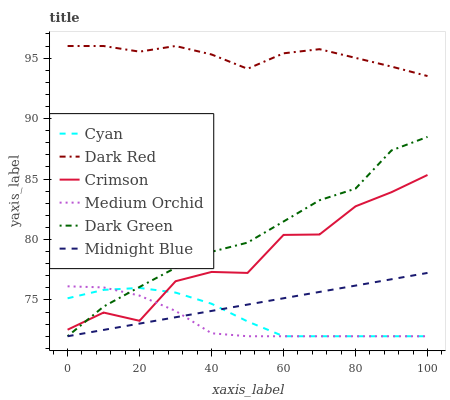Does Medium Orchid have the minimum area under the curve?
Answer yes or no. Yes. Does Dark Red have the maximum area under the curve?
Answer yes or no. Yes. Does Dark Red have the minimum area under the curve?
Answer yes or no. No. Does Medium Orchid have the maximum area under the curve?
Answer yes or no. No. Is Midnight Blue the smoothest?
Answer yes or no. Yes. Is Crimson the roughest?
Answer yes or no. Yes. Is Dark Red the smoothest?
Answer yes or no. No. Is Dark Red the roughest?
Answer yes or no. No. Does Midnight Blue have the lowest value?
Answer yes or no. Yes. Does Dark Red have the lowest value?
Answer yes or no. No. Does Dark Red have the highest value?
Answer yes or no. Yes. Does Medium Orchid have the highest value?
Answer yes or no. No. Is Dark Green less than Dark Red?
Answer yes or no. Yes. Is Dark Red greater than Cyan?
Answer yes or no. Yes. Does Crimson intersect Medium Orchid?
Answer yes or no. Yes. Is Crimson less than Medium Orchid?
Answer yes or no. No. Is Crimson greater than Medium Orchid?
Answer yes or no. No. Does Dark Green intersect Dark Red?
Answer yes or no. No. 